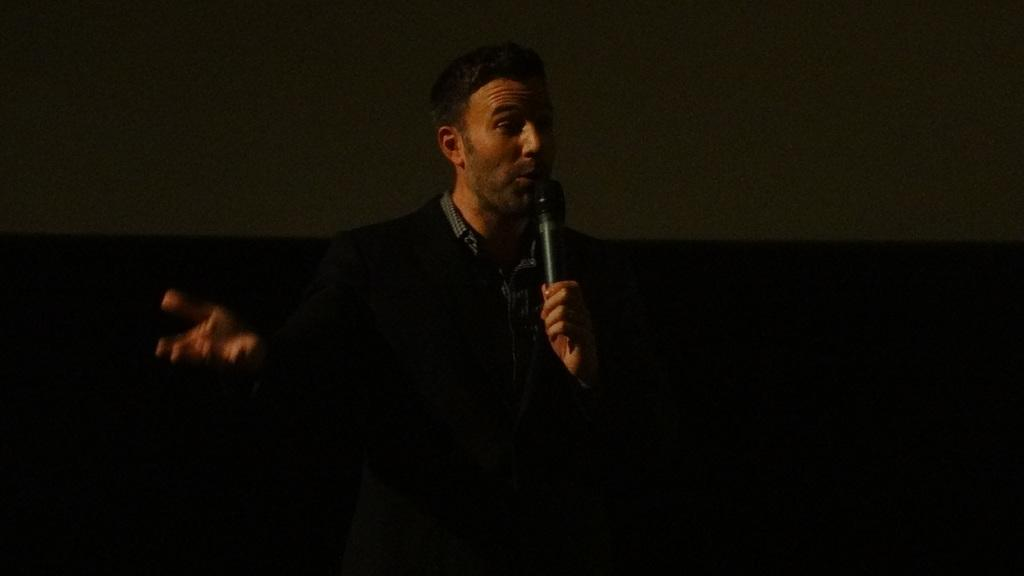Who is the main subject in the picture? There is a man in the picture. What is the man holding in the picture? The man is holding a microphone. What is the man doing with the microphone? The man is talking into the microphone. What type of lettuce can be seen in the picture? There is no lettuce present in the picture. How does the man divide the audience's attention in the picture? The picture does not show the man dividing the audience's attention, as it only depicts him holding and talking into a microphone. 